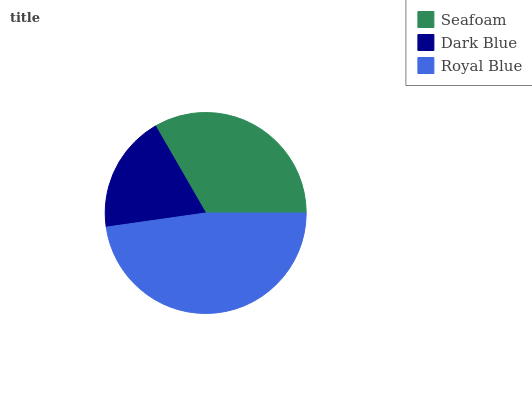Is Dark Blue the minimum?
Answer yes or no. Yes. Is Royal Blue the maximum?
Answer yes or no. Yes. Is Royal Blue the minimum?
Answer yes or no. No. Is Dark Blue the maximum?
Answer yes or no. No. Is Royal Blue greater than Dark Blue?
Answer yes or no. Yes. Is Dark Blue less than Royal Blue?
Answer yes or no. Yes. Is Dark Blue greater than Royal Blue?
Answer yes or no. No. Is Royal Blue less than Dark Blue?
Answer yes or no. No. Is Seafoam the high median?
Answer yes or no. Yes. Is Seafoam the low median?
Answer yes or no. Yes. Is Royal Blue the high median?
Answer yes or no. No. Is Royal Blue the low median?
Answer yes or no. No. 